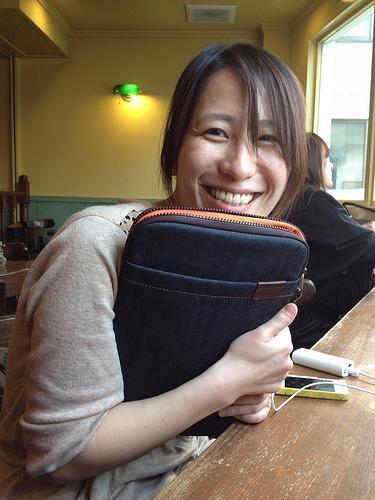How many people are wearing grey shirts?
Give a very brief answer. 1. 